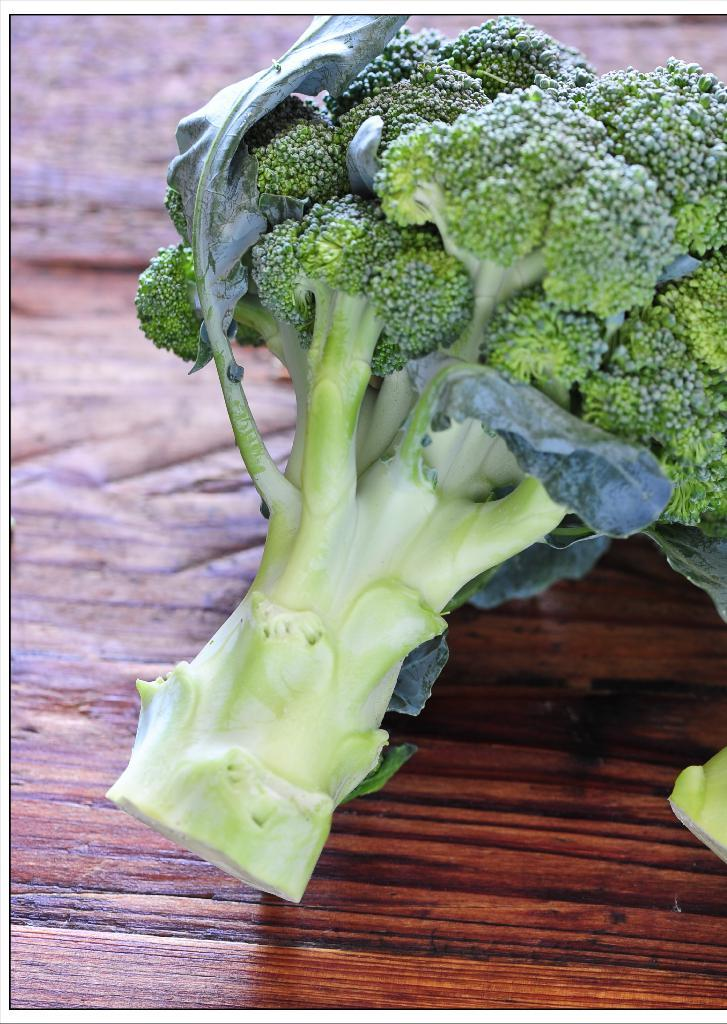What type of vegetable is present in the image? There is a broccoli in the image. On what surface is the broccoli placed? The broccoli is on a wooden surface. How does the broccoli maintain its balance on the wooden surface? The broccoli does not need to maintain its balance, as it is a stationary object in the image. 